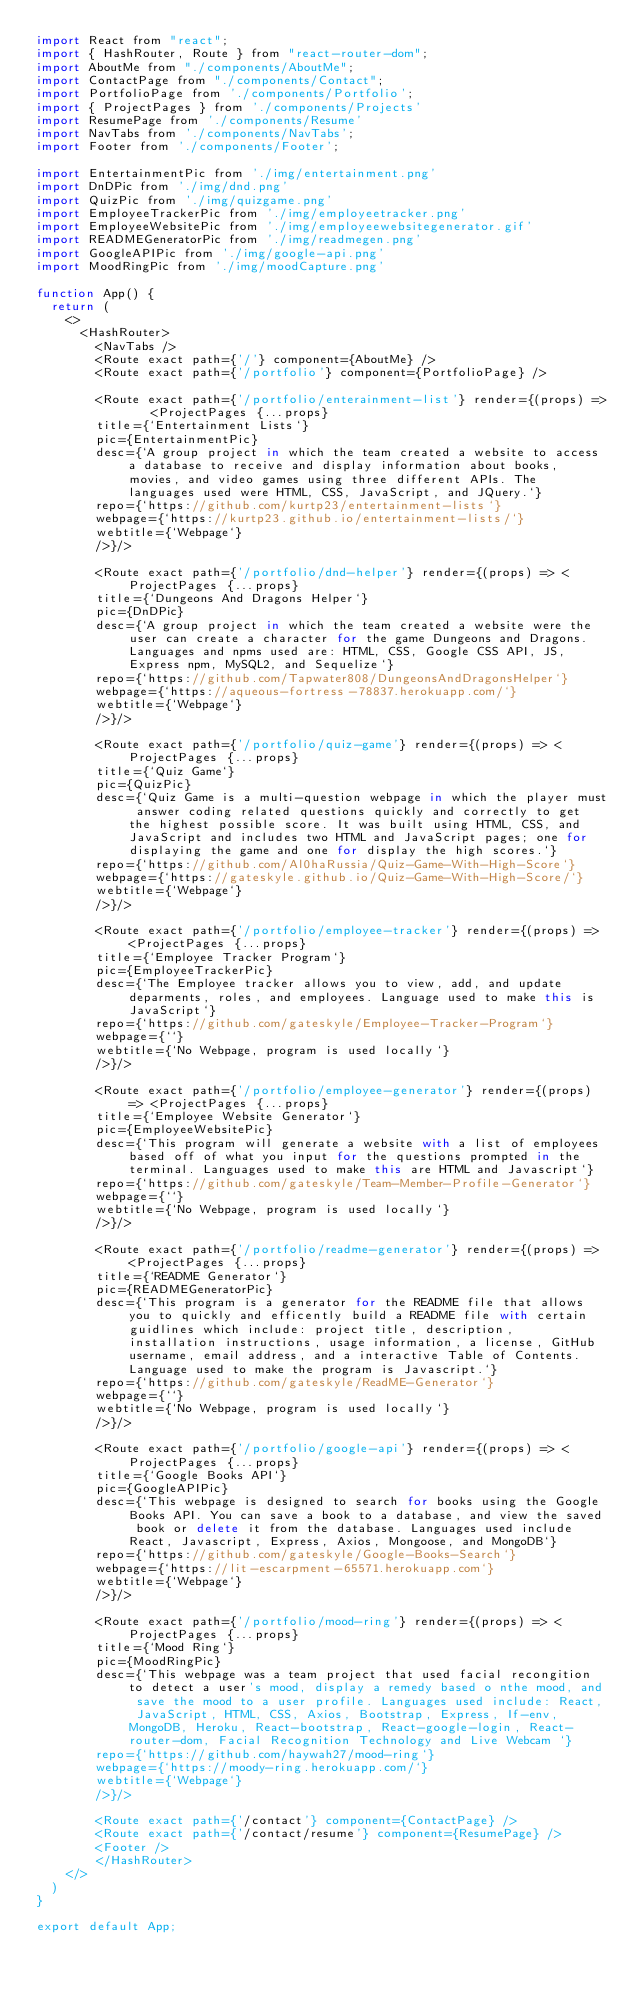Convert code to text. <code><loc_0><loc_0><loc_500><loc_500><_JavaScript_>import React from "react";
import { HashRouter, Route } from "react-router-dom";
import AboutMe from "./components/AboutMe";
import ContactPage from "./components/Contact";
import PortfolioPage from './components/Portfolio';
import { ProjectPages } from './components/Projects'
import ResumePage from './components/Resume'
import NavTabs from './components/NavTabs';
import Footer from './components/Footer';

import EntertainmentPic from './img/entertainment.png'
import DnDPic from './img/dnd.png'
import QuizPic from './img/quizgame.png'
import EmployeeTrackerPic from './img/employeetracker.png'
import EmployeeWebsitePic from './img/employeewebsitegenerator.gif'
import READMEGeneratorPic from './img/readmegen.png'
import GoogleAPIPic from './img/google-api.png'
import MoodRingPic from './img/moodCapture.png'

function App() {
  return (
    <>
      <HashRouter>
        <NavTabs />
        <Route exact path={'/'} component={AboutMe} />
        <Route exact path={'/portfolio'} component={PortfolioPage} />
        
        <Route exact path={'/portfolio/enterainment-list'} render={(props) =>   <ProjectPages {...props} 
        title={`Entertainment Lists`} 
        pic={EntertainmentPic} 
        desc={`A group project in which the team created a website to access a database to receive and display information about books, movies, and video games using three different APIs. The languages used were HTML, CSS, JavaScript, and JQuery.`}
        repo={`https://github.com/kurtp23/entertainment-lists`}
        webpage={`https://kurtp23.github.io/entertainment-lists/`}
        webtitle={`Webpage`}
        />}/>

        <Route exact path={'/portfolio/dnd-helper'} render={(props) => <ProjectPages {...props} 
        title={`Dungeons And Dragons Helper`} 
        pic={DnDPic} 
        desc={`A group project in which the team created a website were the user can create a character for the game Dungeons and Dragons. Languages and npms used are: HTML, CSS, Google CSS API, JS, Express npm, MySQL2, and Sequelize`}
        repo={`https://github.com/Tapwater808/DungeonsAndDragonsHelper`}
        webpage={`https://aqueous-fortress-78837.herokuapp.com/`}
        webtitle={`Webpage`}
        />}/>
        
        <Route exact path={'/portfolio/quiz-game'} render={(props) => <ProjectPages {...props} 
        title={`Quiz Game`} 
        pic={QuizPic} 
        desc={`Quiz Game is a multi-question webpage in which the player must answer coding related questions quickly and correctly to get the highest possible score. It was built using HTML, CSS, and JavaScript and includes two HTML and JavaScript pages; one for displaying the game and one for display the high scores.`}
        repo={`https://github.com/Al0haRussia/Quiz-Game-With-High-Score`}
        webpage={`https://gateskyle.github.io/Quiz-Game-With-High-Score/`}
        webtitle={`Webpage`}
        />}/>

        <Route exact path={'/portfolio/employee-tracker'} render={(props) => <ProjectPages {...props} 
        title={`Employee Tracker Program`} 
        pic={EmployeeTrackerPic} 
        desc={`The Employee tracker allows you to view, add, and update deparments, roles, and employees. Language used to make this is JavaScript`}
        repo={`https://github.com/gateskyle/Employee-Tracker-Program`}
        webpage={``}
        webtitle={`No Webpage, program is used locally`}
        />}/>

        <Route exact path={'/portfolio/employee-generator'} render={(props) => <ProjectPages {...props} 
        title={`Employee Website Generator`} 
        pic={EmployeeWebsitePic} 
        desc={`This program will generate a website with a list of employees based off of what you input for the questions prompted in the terminal. Languages used to make this are HTML and Javascript`}
        repo={`https://github.com/gateskyle/Team-Member-Profile-Generator`}
        webpage={``}
        webtitle={`No Webpage, program is used locally`}
        />}/>

        <Route exact path={'/portfolio/readme-generator'} render={(props) => <ProjectPages {...props} 
        title={`README Generator`} 
        pic={READMEGeneratorPic} 
        desc={`This program is a generator for the README file that allows you to quickly and efficently build a README file with certain guidlines which include: project title, description, installation instructions, usage information, a license, GitHub username, email address, and a interactive Table of Contents. Language used to make the program is Javascript.`}
        repo={`https://github.com/gateskyle/ReadME-Generator`}
        webpage={``}
        webtitle={`No Webpage, program is used locally`}
        />}/>

        <Route exact path={'/portfolio/google-api'} render={(props) => <ProjectPages {...props} 
        title={`Google Books API`} 
        pic={GoogleAPIPic} 
        desc={`This webpage is designed to search for books using the Google Books API. You can save a book to a database, and view the saved book or delete it from the database. Languages used include React, Javascript, Express, Axios, Mongoose, and MongoDB`}
        repo={`https://github.com/gateskyle/Google-Books-Search`}
        webpage={`https://lit-escarpment-65571.herokuapp.com`}
        webtitle={`Webpage`}
        />}/>

        <Route exact path={'/portfolio/mood-ring'} render={(props) => <ProjectPages {...props} 
        title={`Mood Ring`} 
        pic={MoodRingPic} 
        desc={`This webpage was a team project that used facial recongition to detect a user's mood, display a remedy based o nthe mood, and save the mood to a user profile. Languages used include: React, JavaScript, HTML, CSS, Axios, Bootstrap, Express, If-env, MongoDB, Heroku, React-bootstrap, React-google-login, React-router-dom, Facial Recognition Technology and Live Webcam `}
        repo={`https://github.com/haywah27/mood-ring`}
        webpage={`https://moody-ring.herokuapp.com/`}
        webtitle={`Webpage`}
        />}/>

        <Route exact path={'/contact'} component={ContactPage} />
        <Route exact path={'/contact/resume'} component={ResumePage} />
        <Footer />
        </HashRouter>
    </>
  )
}

export default App;
</code> 